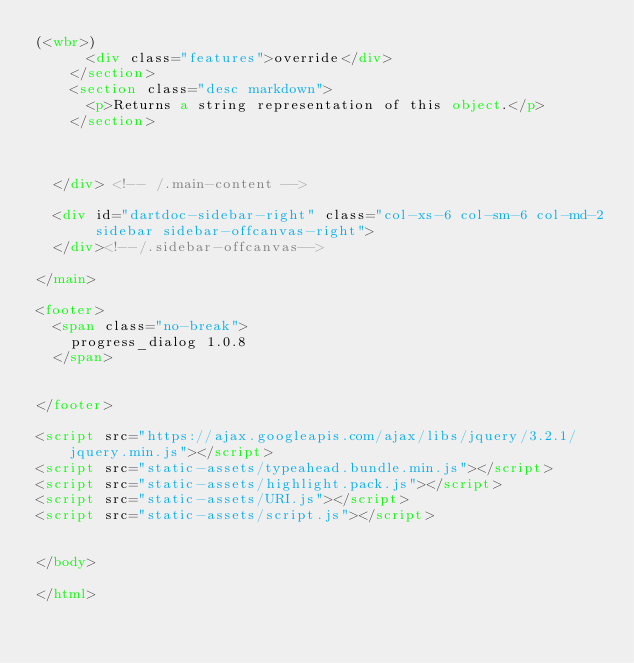Convert code to text. <code><loc_0><loc_0><loc_500><loc_500><_HTML_>(<wbr>)
      <div class="features">override</div>
    </section>
    <section class="desc markdown">
      <p>Returns a string representation of this object.</p>
    </section>
    
    

  </div> <!-- /.main-content -->

  <div id="dartdoc-sidebar-right" class="col-xs-6 col-sm-6 col-md-2 sidebar sidebar-offcanvas-right">
  </div><!--/.sidebar-offcanvas-->

</main>

<footer>
  <span class="no-break">
    progress_dialog 1.0.8
  </span>

  
</footer>

<script src="https://ajax.googleapis.com/ajax/libs/jquery/3.2.1/jquery.min.js"></script>
<script src="static-assets/typeahead.bundle.min.js"></script>
<script src="static-assets/highlight.pack.js"></script>
<script src="static-assets/URI.js"></script>
<script src="static-assets/script.js"></script>


</body>

</html>
</code> 